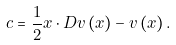<formula> <loc_0><loc_0><loc_500><loc_500>c = \frac { 1 } { 2 } x \cdot D v \left ( x \right ) - v \left ( x \right ) .</formula> 